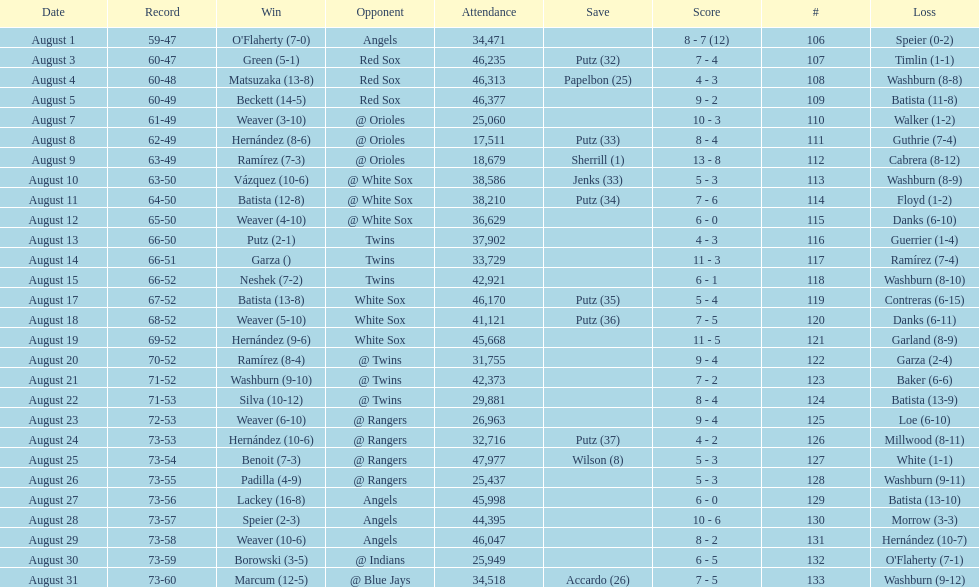What was the total number of games played in august 2007? 28. 